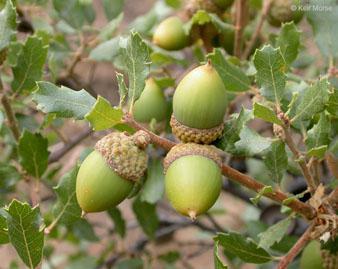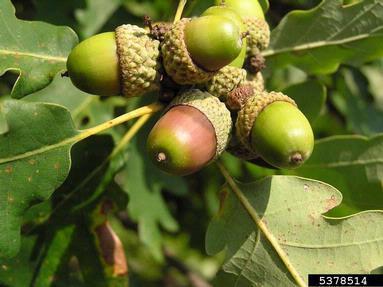The first image is the image on the left, the second image is the image on the right. Evaluate the accuracy of this statement regarding the images: "There are more than five acorns.". Is it true? Answer yes or no. Yes. The first image is the image on the left, the second image is the image on the right. Considering the images on both sides, is "The combined images contain no more than five acorns, and all acorns pictured have the same basic shape." valid? Answer yes or no. No. 